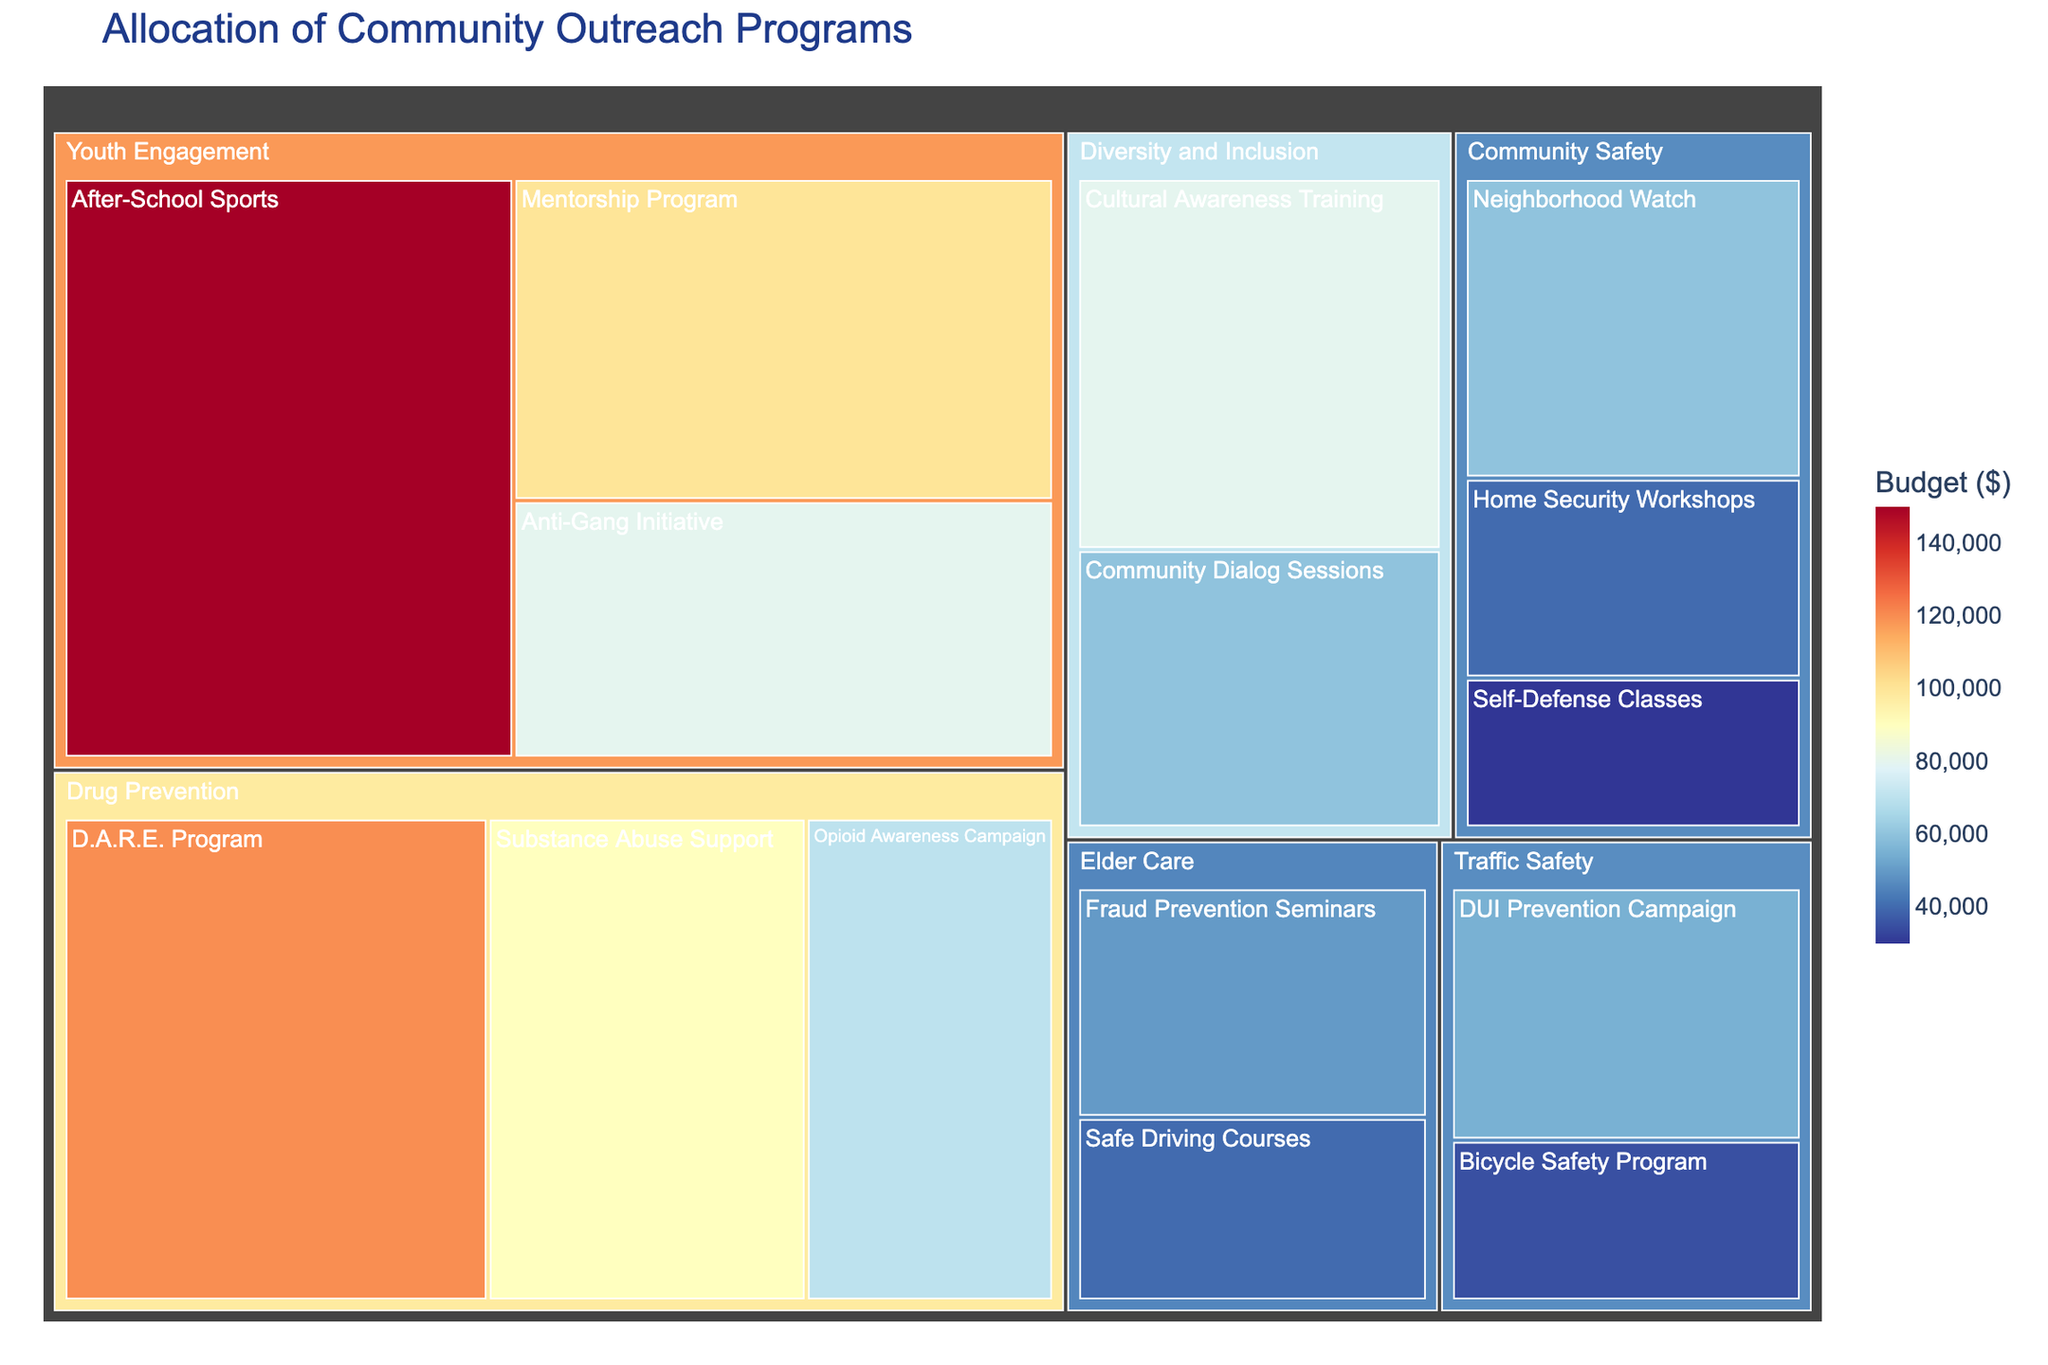What is the title of the figure? The title of the figure is located at the top and describes what the figure is about. By reading the title, we understand what the data represents.
Answer: Allocation of Community Outreach Programs Which category has the largest budget allocation? To determine this, we need to identify the category with the largest section in the treemap. The area size represents the budget allocation.
Answer: Youth Engagement What is the budget allocated to the Anti-Gang Initiative program targeting High School Students? Find the Anti-Gang Initiative program within the Youth Engagement category and read the value representing its budget.
Answer: $80,000 Which category targets Senior Citizens, and what is its total budget? To answer this, locate all programs targeting Senior Citizens within the treemap. Sum the budgets of these programs.
Answer: Elder Care, $90,000 Compare the budget allocation between the D.A.R.E. Program and the Substance Abuse Support program. Which one has a higher budget? Locate both programs in the Drug Prevention category and compare their budget values.
Answer: D.A.R.E. Program has a higher budget How does the budget for the Bicycle Safety Program compare to the Home Security Workshops? Identify both programs and compare their budget values to see which one is higher.
Answer: Home Security Workshops has a higher budget What is the total budget allocated to Community Safety programs? Sum the budgets of all programs within the Community Safety category.
Answer: $130,000 Which program in the Diversity and Inclusion category has a larger budget? Compare the budgets of the programs within the Diversity and Inclusion category to identify the one with the larger allocation.
Answer: Cultural Awareness Training What is the average budget of programs targeting Adults? Identify all programs targeting Adults, sum their budgets, and divide by the number of those programs.
Answer: ($60,000 + $90,000)/2 = $75,000 Which category has the most number of programs? Count the number of programs in each category to determine which has the most.
Answer: Youth Engagement 